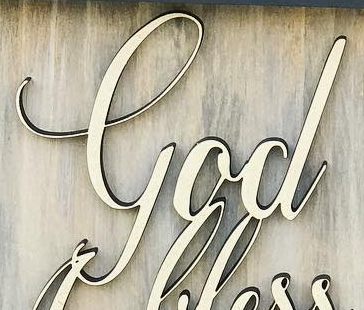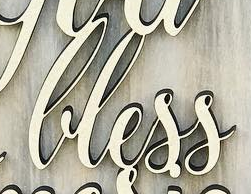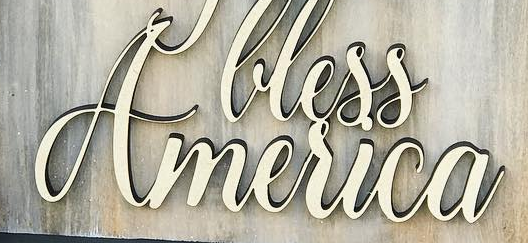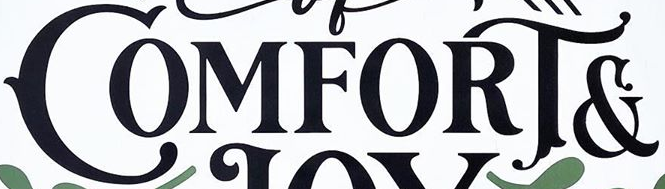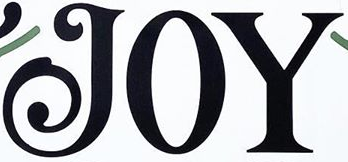Identify the words shown in these images in order, separated by a semicolon. God; lless; America; COMFORT&; JOY 